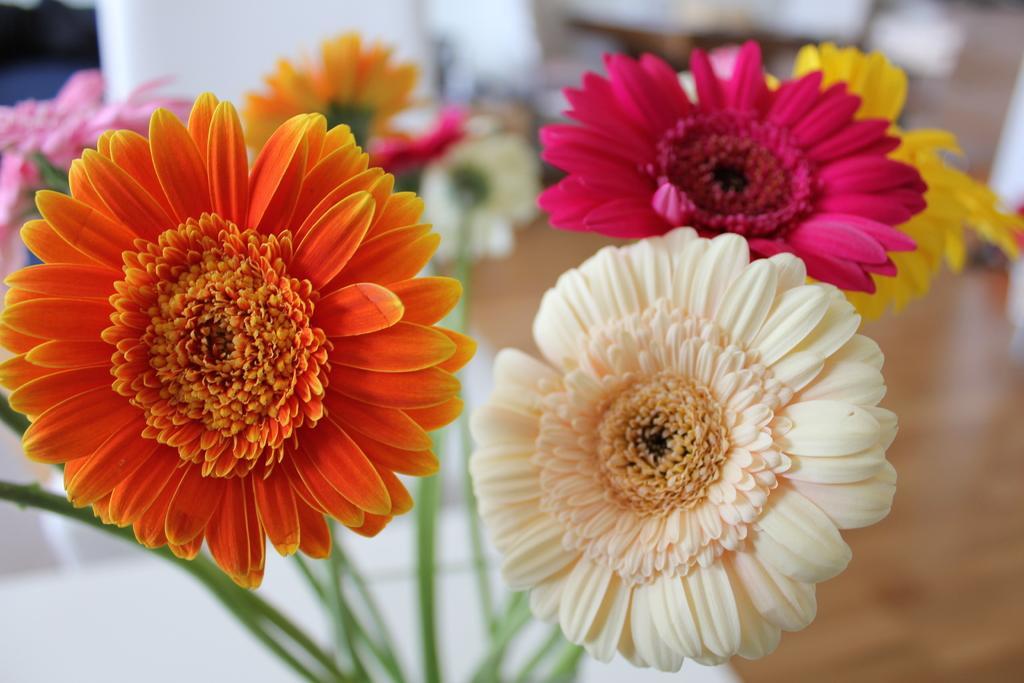In one or two sentences, can you explain what this image depicts? In this image there are different colors of flowers are in middle of this image. 